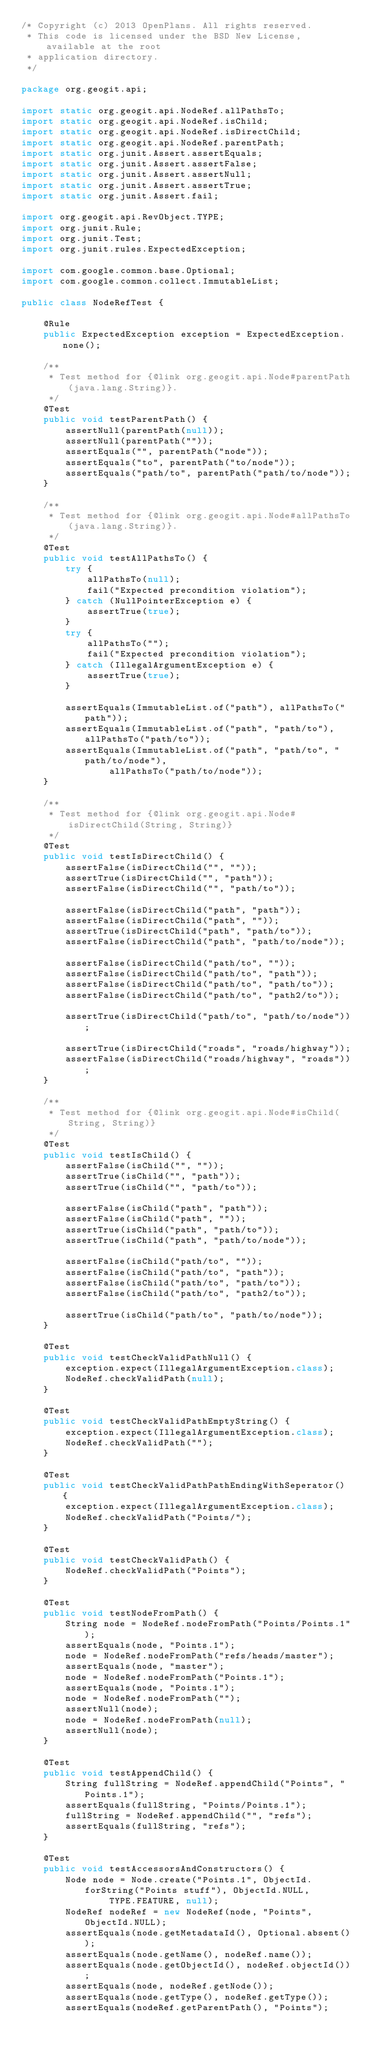<code> <loc_0><loc_0><loc_500><loc_500><_Java_>/* Copyright (c) 2013 OpenPlans. All rights reserved.
 * This code is licensed under the BSD New License, available at the root
 * application directory.
 */

package org.geogit.api;

import static org.geogit.api.NodeRef.allPathsTo;
import static org.geogit.api.NodeRef.isChild;
import static org.geogit.api.NodeRef.isDirectChild;
import static org.geogit.api.NodeRef.parentPath;
import static org.junit.Assert.assertEquals;
import static org.junit.Assert.assertFalse;
import static org.junit.Assert.assertNull;
import static org.junit.Assert.assertTrue;
import static org.junit.Assert.fail;

import org.geogit.api.RevObject.TYPE;
import org.junit.Rule;
import org.junit.Test;
import org.junit.rules.ExpectedException;

import com.google.common.base.Optional;
import com.google.common.collect.ImmutableList;

public class NodeRefTest {

    @Rule
    public ExpectedException exception = ExpectedException.none();

    /**
     * Test method for {@link org.geogit.api.Node#parentPath(java.lang.String)}.
     */
    @Test
    public void testParentPath() {
        assertNull(parentPath(null));
        assertNull(parentPath(""));
        assertEquals("", parentPath("node"));
        assertEquals("to", parentPath("to/node"));
        assertEquals("path/to", parentPath("path/to/node"));
    }

    /**
     * Test method for {@link org.geogit.api.Node#allPathsTo(java.lang.String)}.
     */
    @Test
    public void testAllPathsTo() {
        try {
            allPathsTo(null);
            fail("Expected precondition violation");
        } catch (NullPointerException e) {
            assertTrue(true);
        }
        try {
            allPathsTo("");
            fail("Expected precondition violation");
        } catch (IllegalArgumentException e) {
            assertTrue(true);
        }

        assertEquals(ImmutableList.of("path"), allPathsTo("path"));
        assertEquals(ImmutableList.of("path", "path/to"), allPathsTo("path/to"));
        assertEquals(ImmutableList.of("path", "path/to", "path/to/node"),
                allPathsTo("path/to/node"));
    }

    /**
     * Test method for {@link org.geogit.api.Node#isDirectChild(String, String)}
     */
    @Test
    public void testIsDirectChild() {
        assertFalse(isDirectChild("", ""));
        assertTrue(isDirectChild("", "path"));
        assertFalse(isDirectChild("", "path/to"));

        assertFalse(isDirectChild("path", "path"));
        assertFalse(isDirectChild("path", ""));
        assertTrue(isDirectChild("path", "path/to"));
        assertFalse(isDirectChild("path", "path/to/node"));

        assertFalse(isDirectChild("path/to", ""));
        assertFalse(isDirectChild("path/to", "path"));
        assertFalse(isDirectChild("path/to", "path/to"));
        assertFalse(isDirectChild("path/to", "path2/to"));

        assertTrue(isDirectChild("path/to", "path/to/node"));

        assertTrue(isDirectChild("roads", "roads/highway"));
        assertFalse(isDirectChild("roads/highway", "roads"));
    }

    /**
     * Test method for {@link org.geogit.api.Node#isChild(String, String)}
     */
    @Test
    public void testIsChild() {
        assertFalse(isChild("", ""));
        assertTrue(isChild("", "path"));
        assertTrue(isChild("", "path/to"));

        assertFalse(isChild("path", "path"));
        assertFalse(isChild("path", ""));
        assertTrue(isChild("path", "path/to"));
        assertTrue(isChild("path", "path/to/node"));

        assertFalse(isChild("path/to", ""));
        assertFalse(isChild("path/to", "path"));
        assertFalse(isChild("path/to", "path/to"));
        assertFalse(isChild("path/to", "path2/to"));

        assertTrue(isChild("path/to", "path/to/node"));
    }

    @Test
    public void testCheckValidPathNull() {
        exception.expect(IllegalArgumentException.class);
        NodeRef.checkValidPath(null);
    }

    @Test
    public void testCheckValidPathEmptyString() {
        exception.expect(IllegalArgumentException.class);
        NodeRef.checkValidPath("");
    }

    @Test
    public void testCheckValidPathPathEndingWithSeperator() {
        exception.expect(IllegalArgumentException.class);
        NodeRef.checkValidPath("Points/");
    }

    @Test
    public void testCheckValidPath() {
        NodeRef.checkValidPath("Points");
    }

    @Test
    public void testNodeFromPath() {
        String node = NodeRef.nodeFromPath("Points/Points.1");
        assertEquals(node, "Points.1");
        node = NodeRef.nodeFromPath("refs/heads/master");
        assertEquals(node, "master");
        node = NodeRef.nodeFromPath("Points.1");
        assertEquals(node, "Points.1");
        node = NodeRef.nodeFromPath("");
        assertNull(node);
        node = NodeRef.nodeFromPath(null);
        assertNull(node);
    }

    @Test
    public void testAppendChild() {
        String fullString = NodeRef.appendChild("Points", "Points.1");
        assertEquals(fullString, "Points/Points.1");
        fullString = NodeRef.appendChild("", "refs");
        assertEquals(fullString, "refs");
    }

    @Test
    public void testAccessorsAndConstructors() {
        Node node = Node.create("Points.1", ObjectId.forString("Points stuff"), ObjectId.NULL,
                TYPE.FEATURE, null);
        NodeRef nodeRef = new NodeRef(node, "Points", ObjectId.NULL);
        assertEquals(node.getMetadataId(), Optional.absent());
        assertEquals(node.getName(), nodeRef.name());
        assertEquals(node.getObjectId(), nodeRef.objectId());
        assertEquals(node, nodeRef.getNode());
        assertEquals(node.getType(), nodeRef.getType());
        assertEquals(nodeRef.getParentPath(), "Points");</code> 